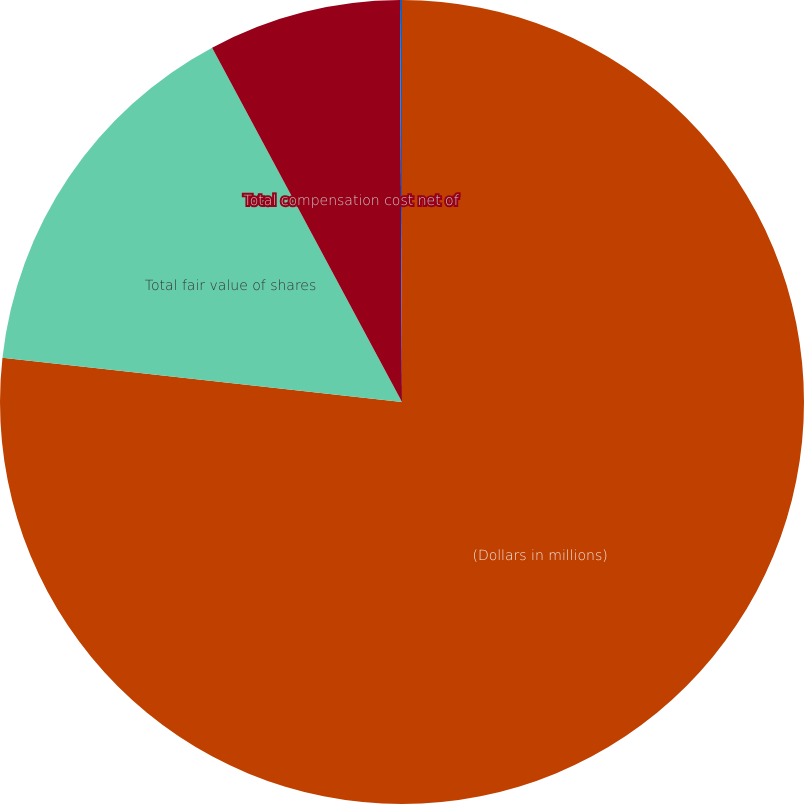Convert chart to OTSL. <chart><loc_0><loc_0><loc_500><loc_500><pie_chart><fcel>(Dollars in millions)<fcel>Total fair value of shares<fcel>Total compensation cost net of<fcel>Weighted-average period in<nl><fcel>76.76%<fcel>15.41%<fcel>7.75%<fcel>0.08%<nl></chart> 